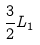Convert formula to latex. <formula><loc_0><loc_0><loc_500><loc_500>\frac { 3 } { 2 } L _ { 1 }</formula> 